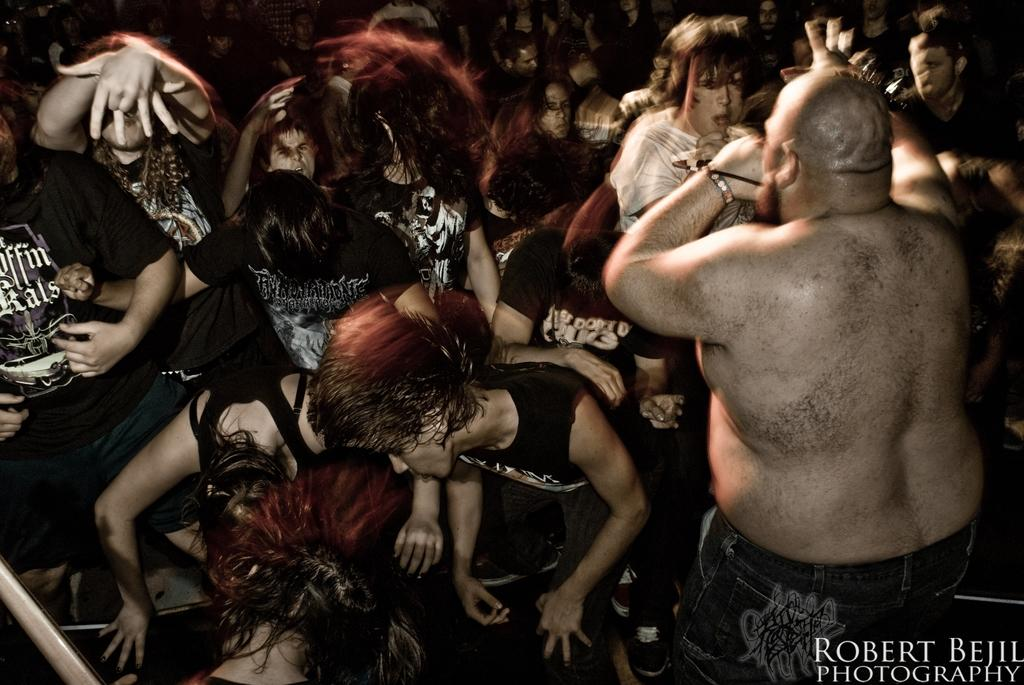What is the main subject of the image? The main subject of the image is a group of people. Can you describe any additional details about the image? Yes, there is text in the bottom right side of the image. Where is the library located in the image? There is no library present in the image. What type of hat is the person in the front wearing? There is no person wearing a hat in the image. 